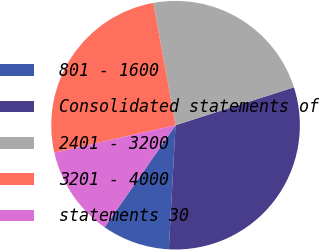<chart> <loc_0><loc_0><loc_500><loc_500><pie_chart><fcel>801 - 1600<fcel>Consolidated statements of<fcel>2401 - 3200<fcel>3201 - 4000<fcel>statements 30<nl><fcel>8.8%<fcel>30.79%<fcel>22.93%<fcel>25.69%<fcel>11.79%<nl></chart> 